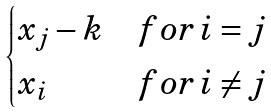<formula> <loc_0><loc_0><loc_500><loc_500>\begin{cases} x _ { j } - k & f o r \, i = j \\ x _ { i } & f o r \, i \neq j \end{cases}</formula> 